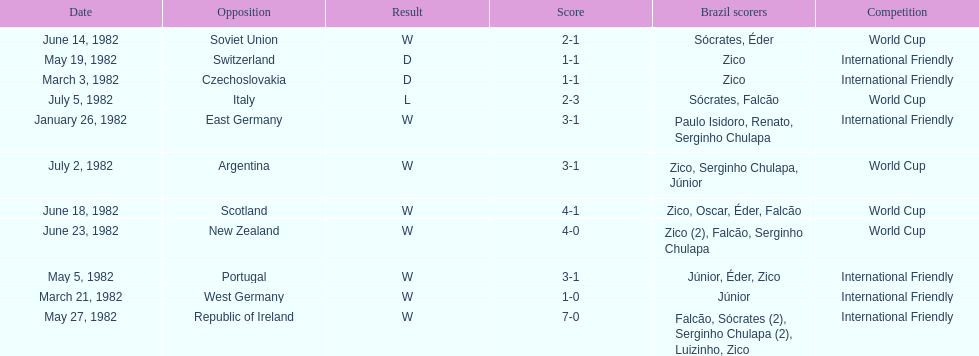What date is at the top of the list? January 26, 1982. 